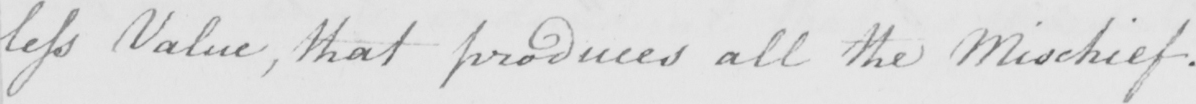Can you tell me what this handwritten text says? less Value , that produces all the Mischief . 